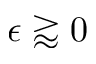<formula> <loc_0><loc_0><loc_500><loc_500>\epsilon \gtrapprox 0</formula> 